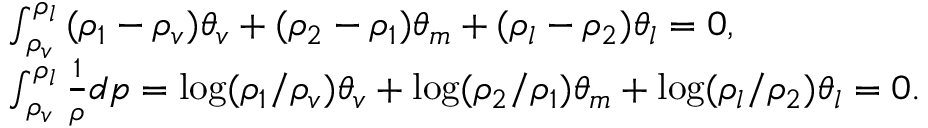<formula> <loc_0><loc_0><loc_500><loc_500>\begin{array} { l } { \int _ { { \rho _ { v } } } ^ { { \rho _ { l } } } { ( { \rho _ { 1 } } - { \rho _ { v } } ) { \theta _ { v } } + ( { \rho _ { 2 } } - { \rho _ { 1 } } ) } { \theta _ { m } } + ( { \rho _ { l } } - { \rho _ { 2 } } ) { \theta _ { l } } = 0 , } \\ { \int _ { { \rho _ { v } } } ^ { { \rho _ { l } } } { \frac { 1 } { \rho } d p = \log ( } { \rho _ { 1 } } / { \rho _ { v } } ) { \theta _ { v } } + \log ( { \rho _ { 2 } } / { \rho _ { 1 } } ) { \theta _ { m } } + \log ( { \rho _ { l } } / { \rho _ { 2 } } ) { \theta _ { l } } = 0 . } \end{array}</formula> 